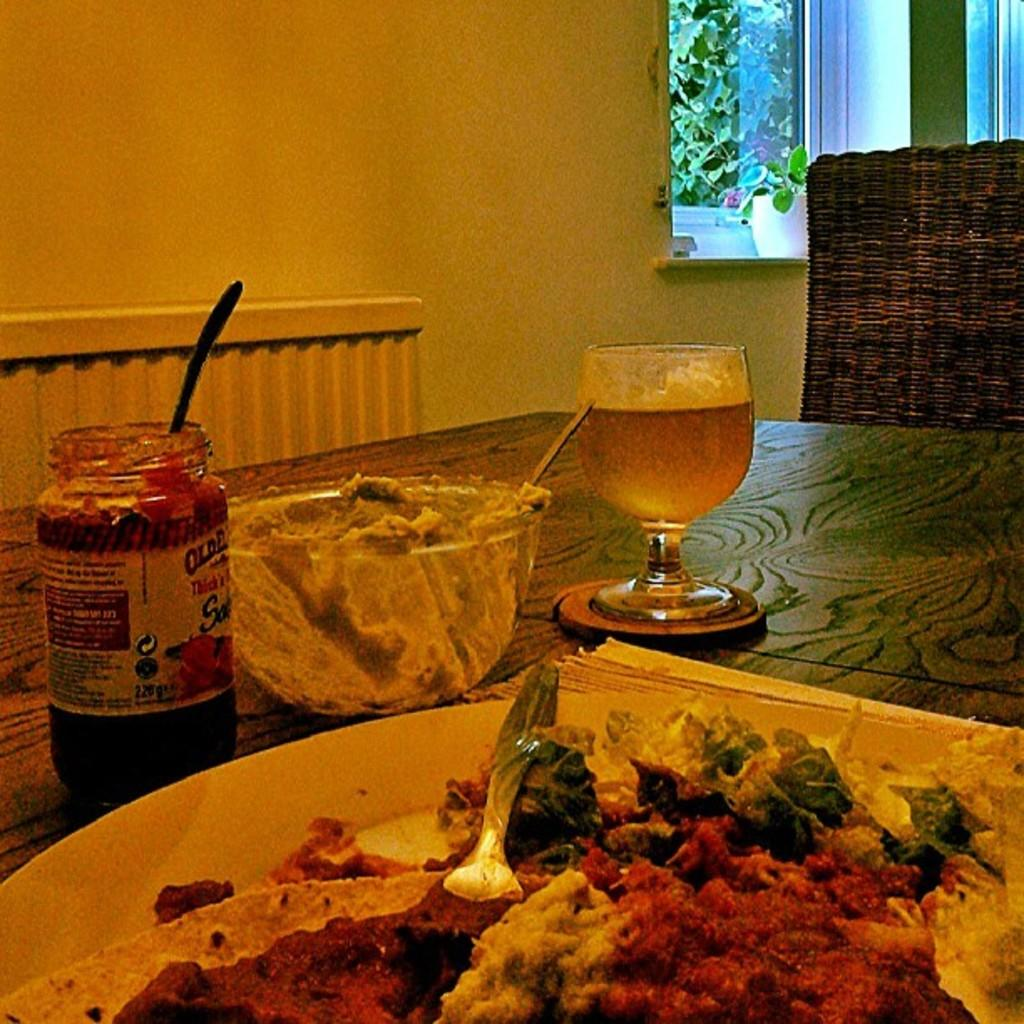What type of furniture is shown in the image? The image depicts a dining table. What is placed on the dining table? There is a plate and a wine glass on the table. Is there any other container on the table? Yes, there is a glass jar on the table. What can be seen outside the window in the image? Trees are visible outside the window. How does the scarecrow move around the dining table in the image? There is no scarecrow present in the image, so it cannot move around the dining table. Can you tell me how many times the glass jar is pushed in the image? There is no indication of any pushing or movement of objects in the image, so it is not possible to answer this question. 